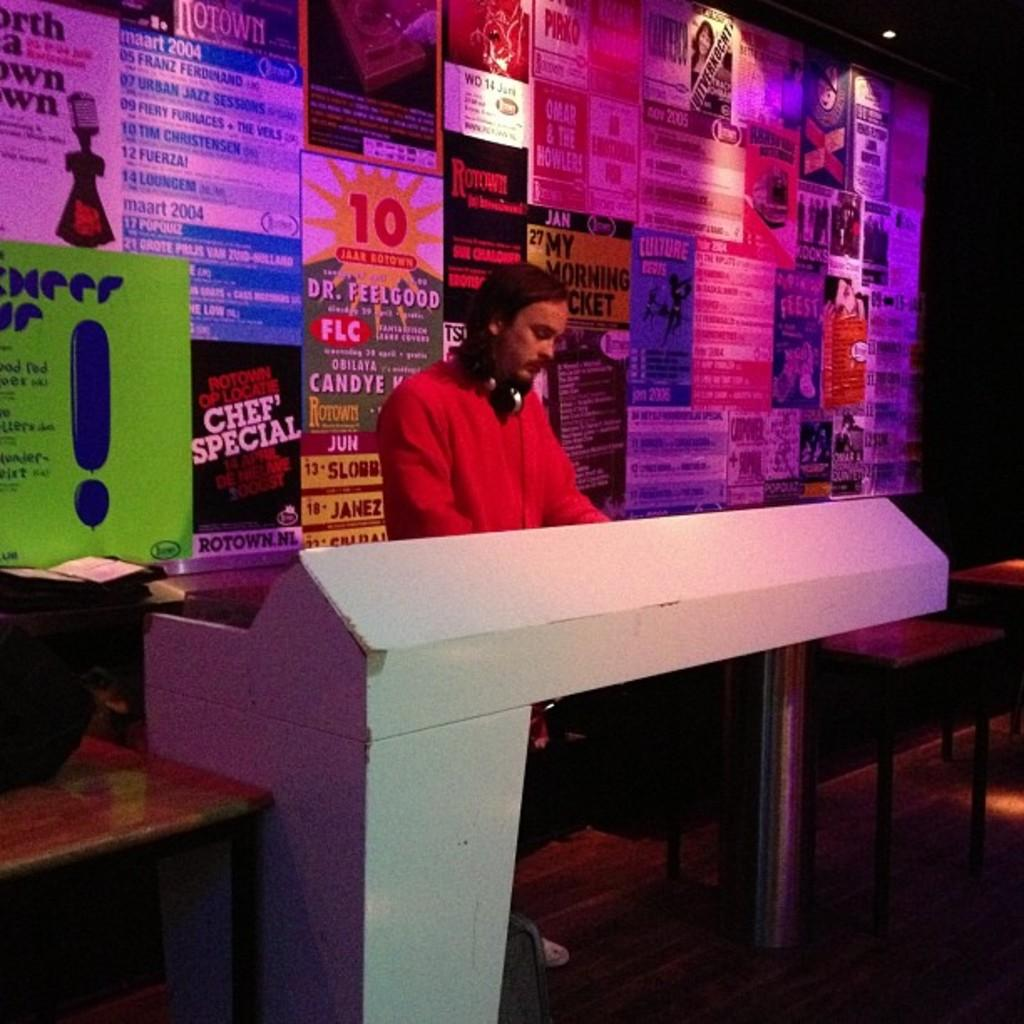<image>
Create a compact narrative representing the image presented. DJ looking focused on something with a "Chef' Special" poster in the background. 